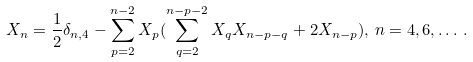<formula> <loc_0><loc_0><loc_500><loc_500>X _ { n } = \frac { 1 } { 2 } \delta _ { n , 4 } - \sum _ { p = 2 } ^ { n - 2 } X _ { p } ( \sum _ { q = 2 } ^ { n - p - 2 } X _ { q } X _ { n - p - q } + 2 X _ { n - p } ) , \, n = 4 , 6 , \dots \, .</formula> 